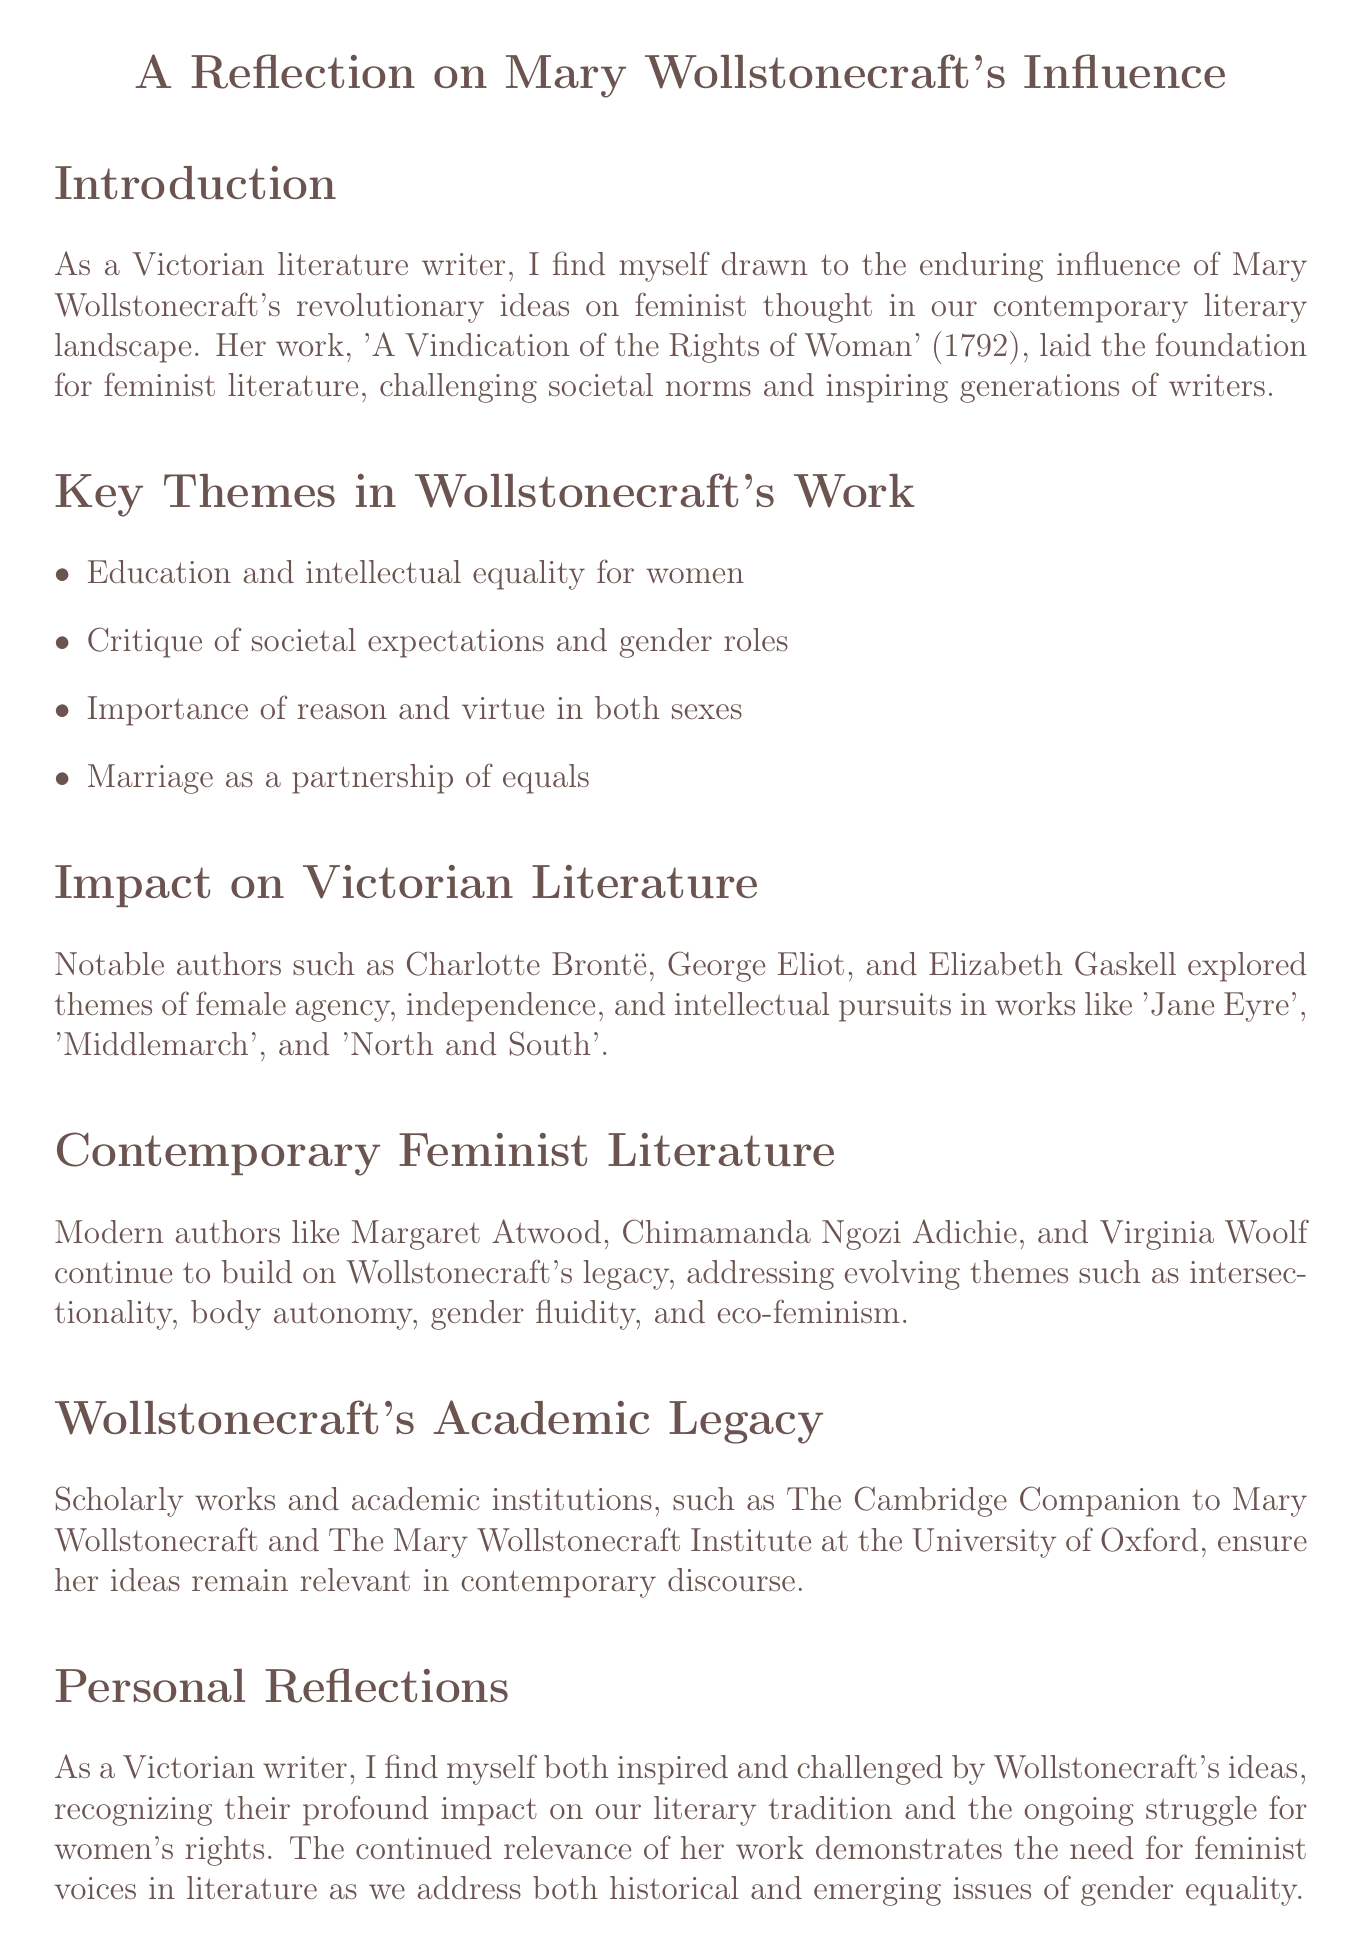what is the title of Wollstonecraft's foundational work? The document identifies 'A Vindication of the Rights of Woman' as Wollstonecraft's foundational work in feminist literature.
Answer: 'A Vindication of the Rights of Woman' who are three notable authors influenced by Wollstonecraft? The document lists Charlotte Brontë, George Eliot, and Elizabeth Gaskell as notable authors influenced by Wollstonecraft.
Answer: Charlotte Brontë, George Eliot, Elizabeth Gaskell what is one theme explored in Victorian literature? The document mentions themes such as female agency and independence as explored in Victorian literature.
Answer: Female agency and independence name a modern author who continues Wollstonecraft's legacy. The document references Margaret Atwood as a modern author continuing Wollstonecraft's legacy.
Answer: Margaret Atwood what evolving theme is discussed in contemporary feminist literature? Intersectionality is mentioned as one of the evolving themes in contemporary feminist literature according to the document.
Answer: Intersectionality what institution is mentioned in relation to Wollstonecraft's academic legacy? The Mary Wollstonecraft Institute at the University of Oxford is mentioned as an institution related to Wollstonecraft's academic legacy.
Answer: The Mary Wollstonecraft Institute at the University of Oxford how does the document describe Wollstonecraft's impact on literature? The impact on literature is described as shaping feminist thought and bridging the gap between the Enlightenment era and contemporary world.
Answer: Shaping feminist thought and bridging the gap what is a key message in the conclusion of the document? The conclusion emphasizes the need for writers to carry forward Wollstonecraft's legacy in advocating for equality.
Answer: Need for writers to carry forward Wollstonecraft's legacy which aspect does the document highlight regarding marriage in Wollstonecraft's work? The document highlights marriage as a partnership of equals according to Wollstonecraft's work.
Answer: A partnership of equals 